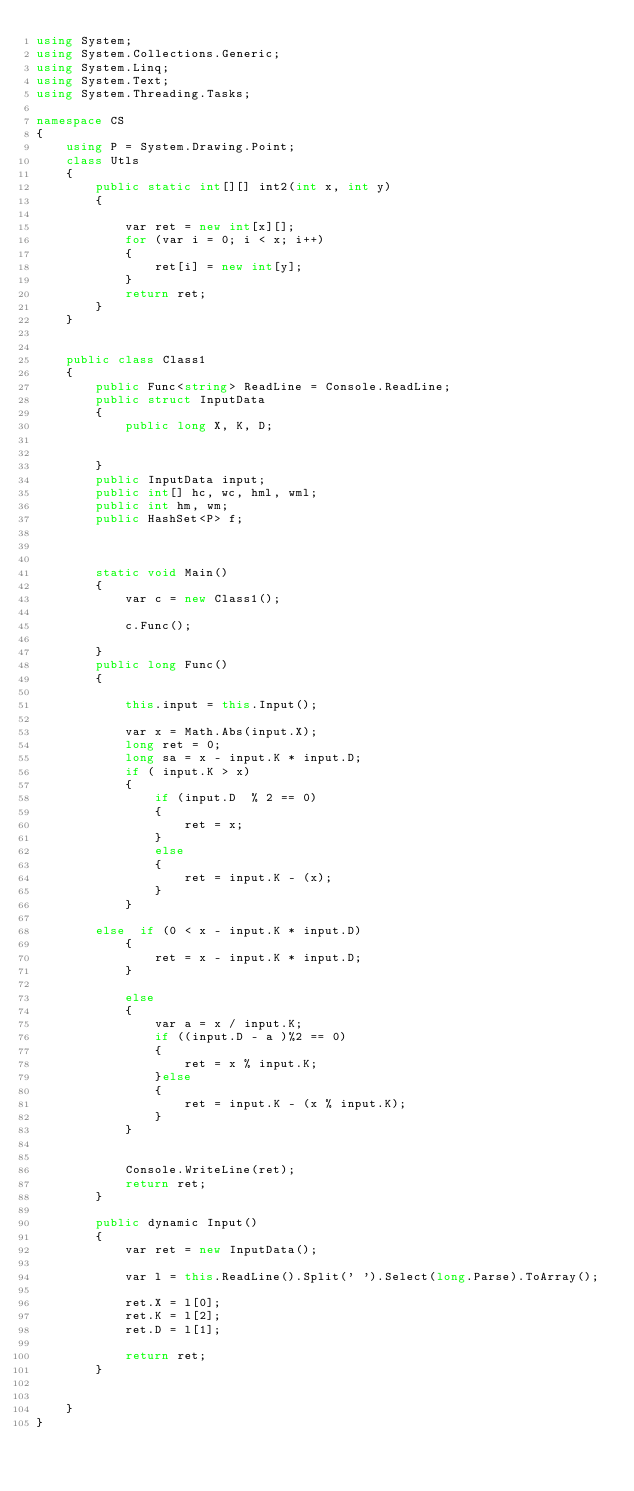<code> <loc_0><loc_0><loc_500><loc_500><_C#_>using System;
using System.Collections.Generic;
using System.Linq;
using System.Text;
using System.Threading.Tasks;

namespace CS
{
    using P = System.Drawing.Point;
    class Utls
    {
        public static int[][] int2(int x, int y)
        {

            var ret = new int[x][];
            for (var i = 0; i < x; i++)
            {
                ret[i] = new int[y];
            }
            return ret;
        }
    }


    public class Class1
    {
        public Func<string> ReadLine = Console.ReadLine;
        public struct InputData
        {
            public long X, K, D;
           

        }
        public InputData input;
        public int[] hc, wc, hml, wml;
        public int hm, wm;
        public HashSet<P> f;



        static void Main()
        {
            var c = new Class1();
           
            c.Func();

        }
        public long Func()
        {

            this.input = this.Input();

            var x = Math.Abs(input.X);
            long ret = 0;
            long sa = x - input.K * input.D;
            if ( input.K > x)
            {
                if (input.D  % 2 == 0)
                {
                    ret = x;
                }
                else
                {
                    ret = input.K - (x);
                }
            }

        else  if (0 < x - input.K * input.D)
            {
                ret = x - input.K * input.D;
            }
          
            else
            {
                var a = x / input.K;
                if ((input.D - a )%2 == 0)
                {
                    ret = x % input.K;
                }else
                {
                    ret = input.K - (x % input.K);
                }
            }


            Console.WriteLine(ret);
            return ret;
        }

        public dynamic Input()
        {
            var ret = new InputData();

            var l = this.ReadLine().Split(' ').Select(long.Parse).ToArray();

            ret.X = l[0];
            ret.K = l[2];
            ret.D = l[1];

            return ret;
        }


    }
}
</code> 